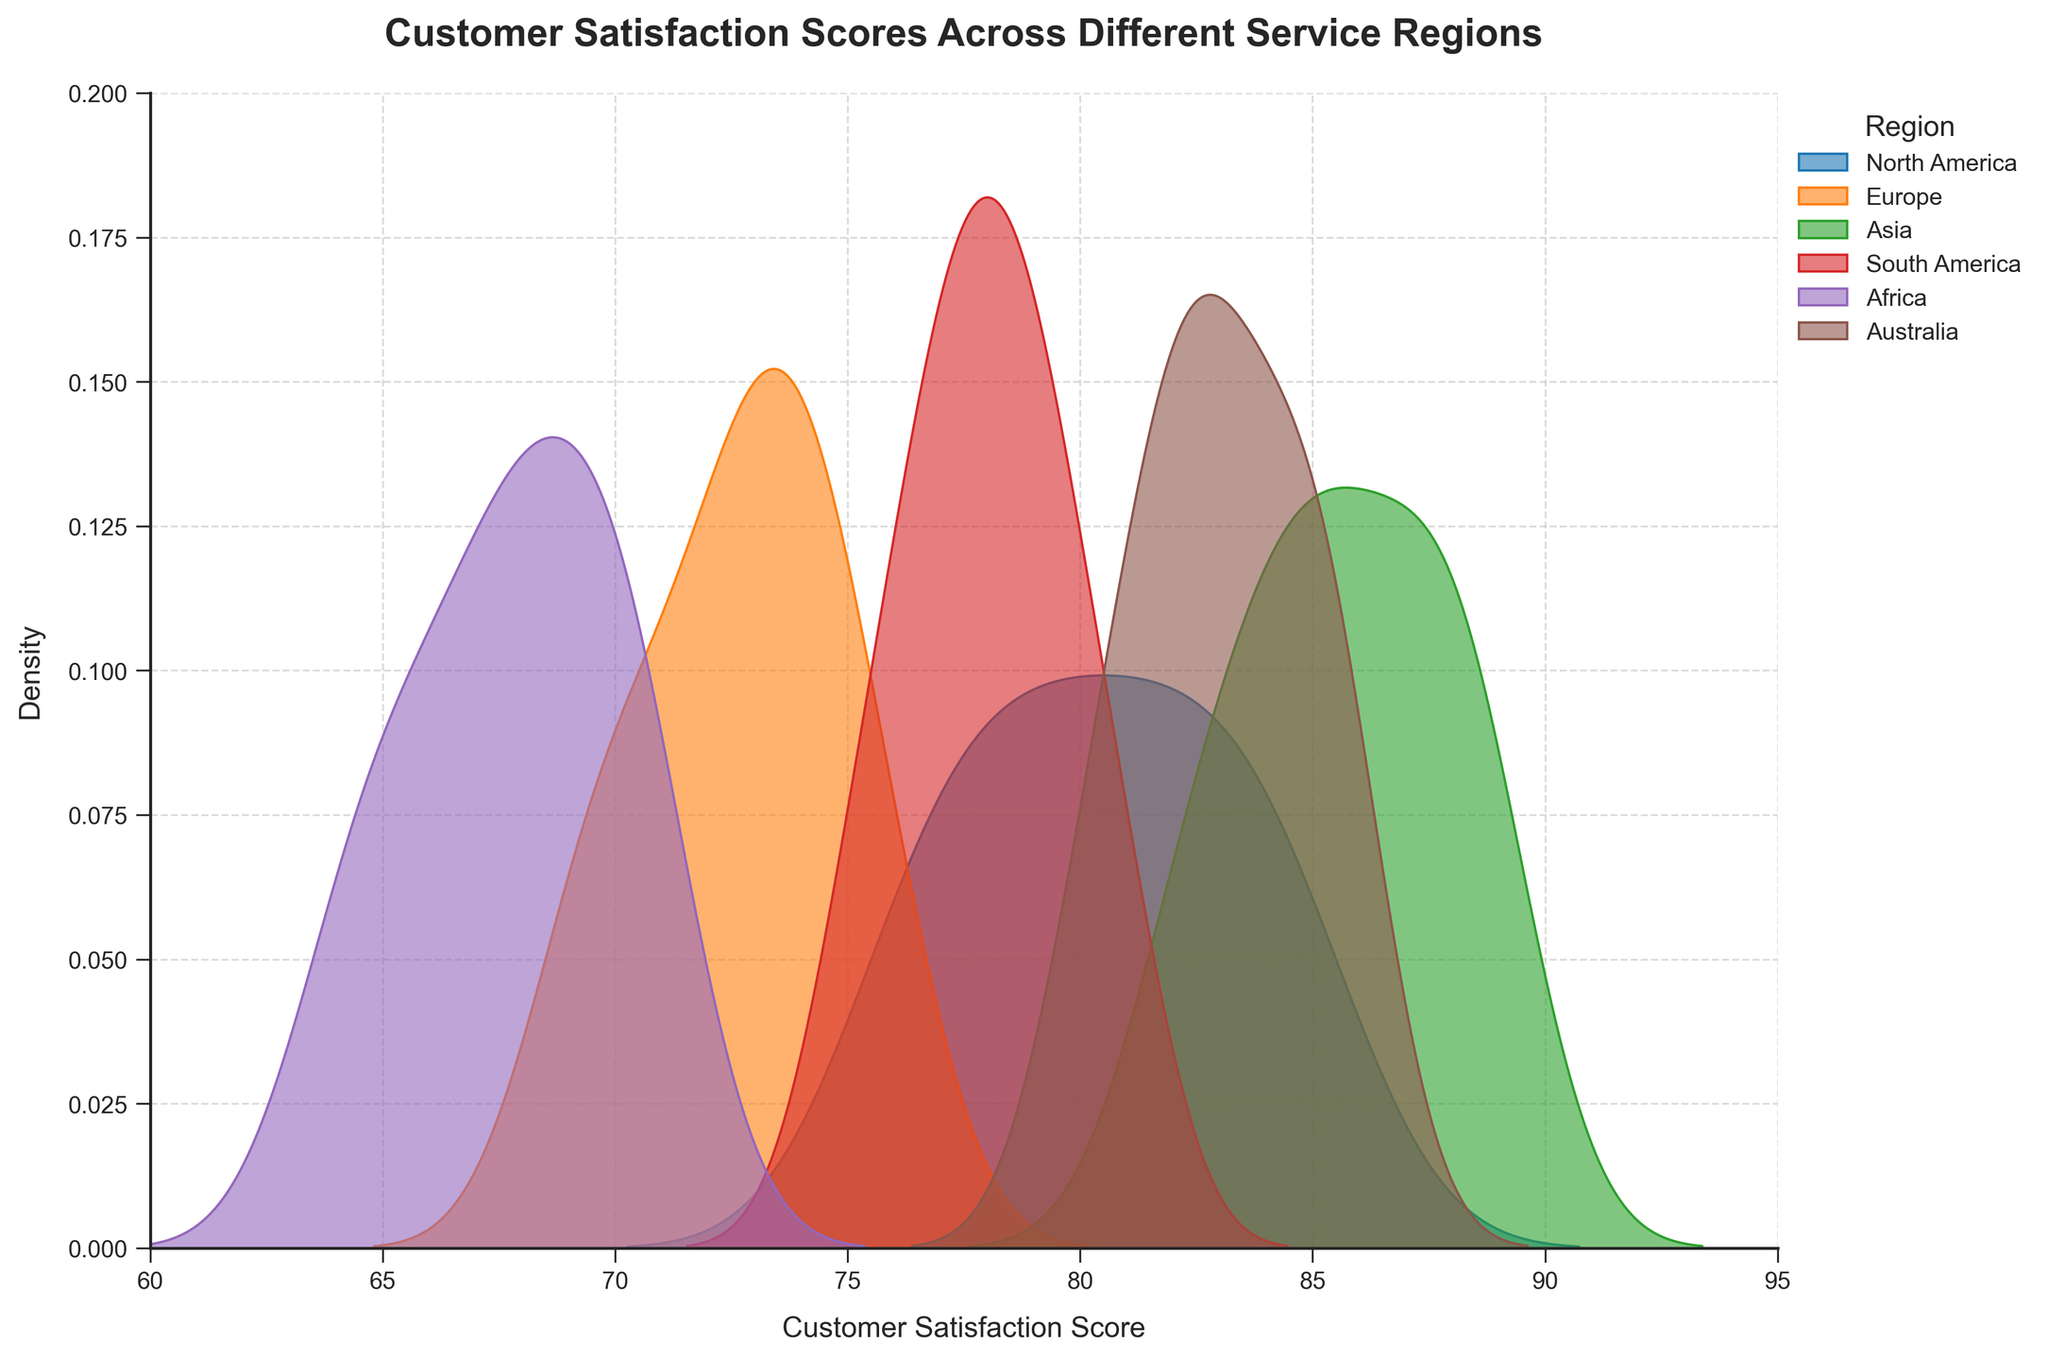What is the title of the figure? The title is displayed at the top of the figure and is formatted in bold, large font.
Answer: Customer Satisfaction Scores Across Different Service Regions What is the x-axis label in the figure? The x-axis label can be seen under the horizontal axis in the figure.
Answer: Customer Satisfaction Score Which region has the highest peak in the density plot? Look at the peaks of each density curve; the region with the highest peak is the one with the most concentrated scores.
Answer: Asia Which region has the lowest range of customer satisfaction scores? Examine the spread of the density curves; the region with the narrowest spread has the lowest range.
Answer: Africa Which region appears to have the most consistent customer satisfaction scores? The region with the sharpest and tallest peak in its density curve shows the highest consistency in scores.
Answer: Asia How do the satisfaction scores of Europe compare to those of Africa? Compare the density plots of Europe and Africa. Europe's curve is more spread out between 70-76, while Africa's curve is more concentrated between 64-71.
Answer: Europe's scores are higher and less consistent Which region has a wider distribution of satisfaction scores, North America or South America? Look at the spread of the density curves for both regions; the one with the wider spread represents a wider distribution.
Answer: North America What is the most frequent customer satisfaction score range for Australia? Identify the peaks in the density plot for Australia; the score at the highest peak indicates the most frequent score range.
Answer: 82-85 Are there any regions with overlapping customer satisfaction scores? If so, which ones? Look where the density curves from different regions overlap; these areas indicate overlapping satisfaction scores.
Answer: Yes, North America and South America Which region's satisfaction scores are more evenly distributed: Europe or Australia? Examine the density plots; a more evenly distributed region will have a flatter and wider density curve.
Answer: Europe 